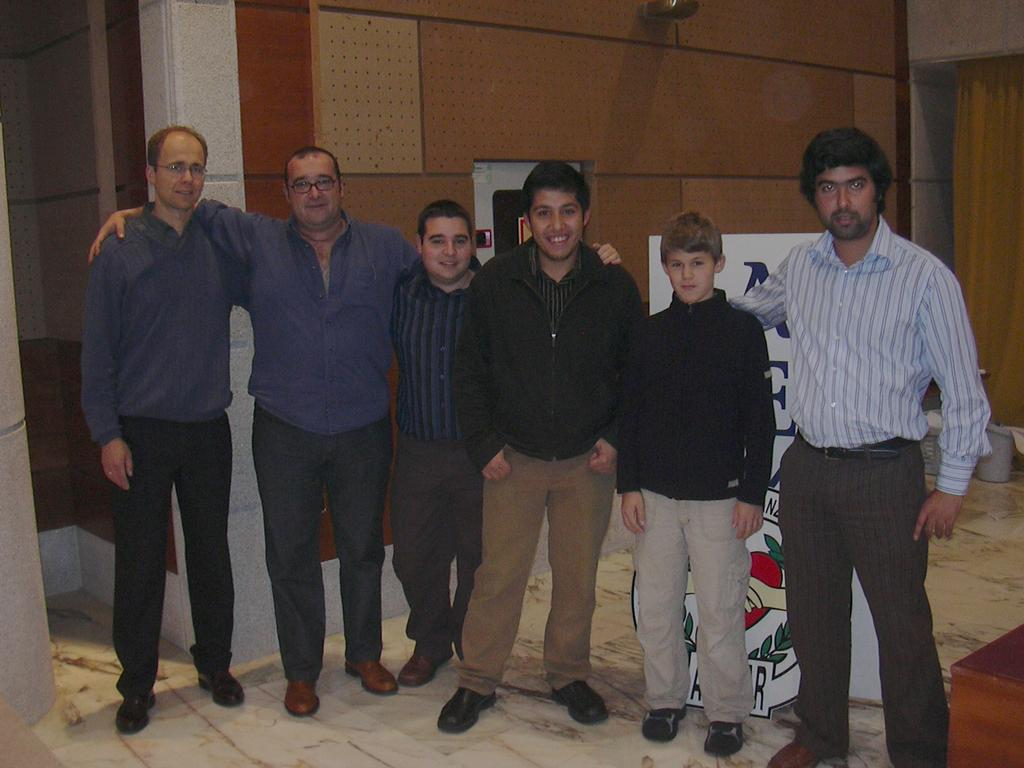What are the people in the image doing? The persons standing on the floor in the image are likely engaged in some activity or standing in a particular setting. What can be seen in the background of the image? There is a board, a brown-colored wall, a curtain, and buckets on the floor in the background of the image. How many frogs can be seen jumping in the image? There are no frogs present in the image. What country is depicted in the image? The image does not depict a specific country; it only shows the persons and the background elements. 